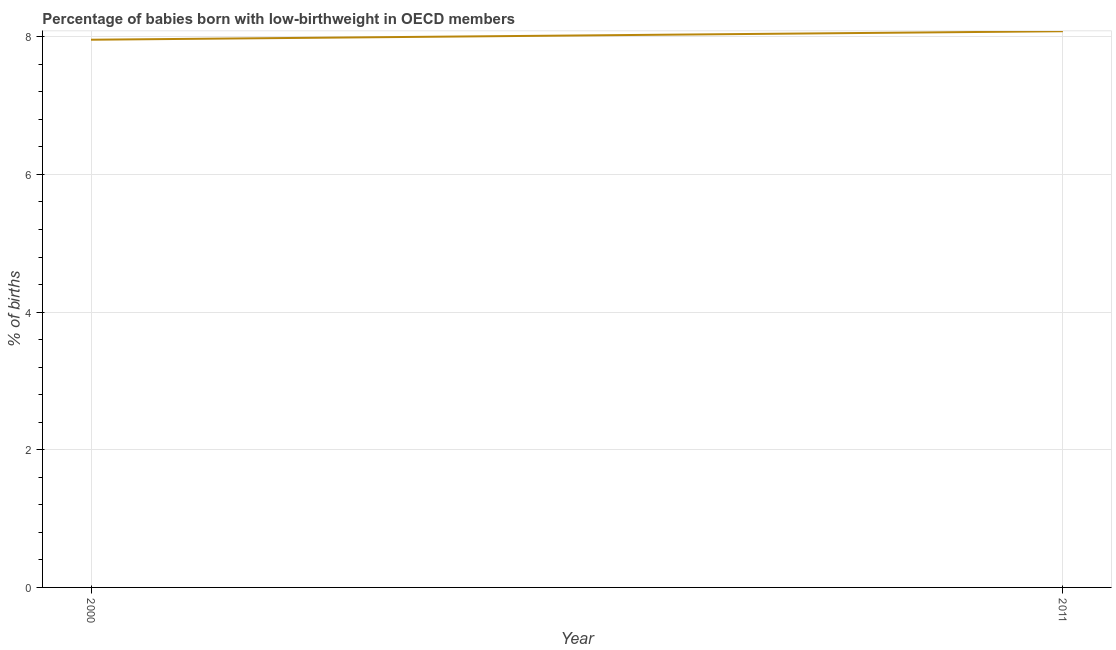What is the percentage of babies who were born with low-birthweight in 2000?
Provide a short and direct response. 7.96. Across all years, what is the maximum percentage of babies who were born with low-birthweight?
Provide a short and direct response. 8.08. Across all years, what is the minimum percentage of babies who were born with low-birthweight?
Make the answer very short. 7.96. What is the sum of the percentage of babies who were born with low-birthweight?
Make the answer very short. 16.04. What is the difference between the percentage of babies who were born with low-birthweight in 2000 and 2011?
Make the answer very short. -0.12. What is the average percentage of babies who were born with low-birthweight per year?
Your answer should be very brief. 8.02. What is the median percentage of babies who were born with low-birthweight?
Make the answer very short. 8.02. In how many years, is the percentage of babies who were born with low-birthweight greater than 1.6 %?
Ensure brevity in your answer.  2. What is the ratio of the percentage of babies who were born with low-birthweight in 2000 to that in 2011?
Your response must be concise. 0.98. Is the percentage of babies who were born with low-birthweight in 2000 less than that in 2011?
Offer a very short reply. Yes. In how many years, is the percentage of babies who were born with low-birthweight greater than the average percentage of babies who were born with low-birthweight taken over all years?
Provide a short and direct response. 1. How many years are there in the graph?
Offer a terse response. 2. Are the values on the major ticks of Y-axis written in scientific E-notation?
Your answer should be compact. No. Does the graph contain any zero values?
Your answer should be compact. No. Does the graph contain grids?
Offer a terse response. Yes. What is the title of the graph?
Your response must be concise. Percentage of babies born with low-birthweight in OECD members. What is the label or title of the Y-axis?
Provide a succinct answer. % of births. What is the % of births in 2000?
Your answer should be very brief. 7.96. What is the % of births of 2011?
Give a very brief answer. 8.08. What is the difference between the % of births in 2000 and 2011?
Your answer should be compact. -0.12. What is the ratio of the % of births in 2000 to that in 2011?
Ensure brevity in your answer.  0.98. 